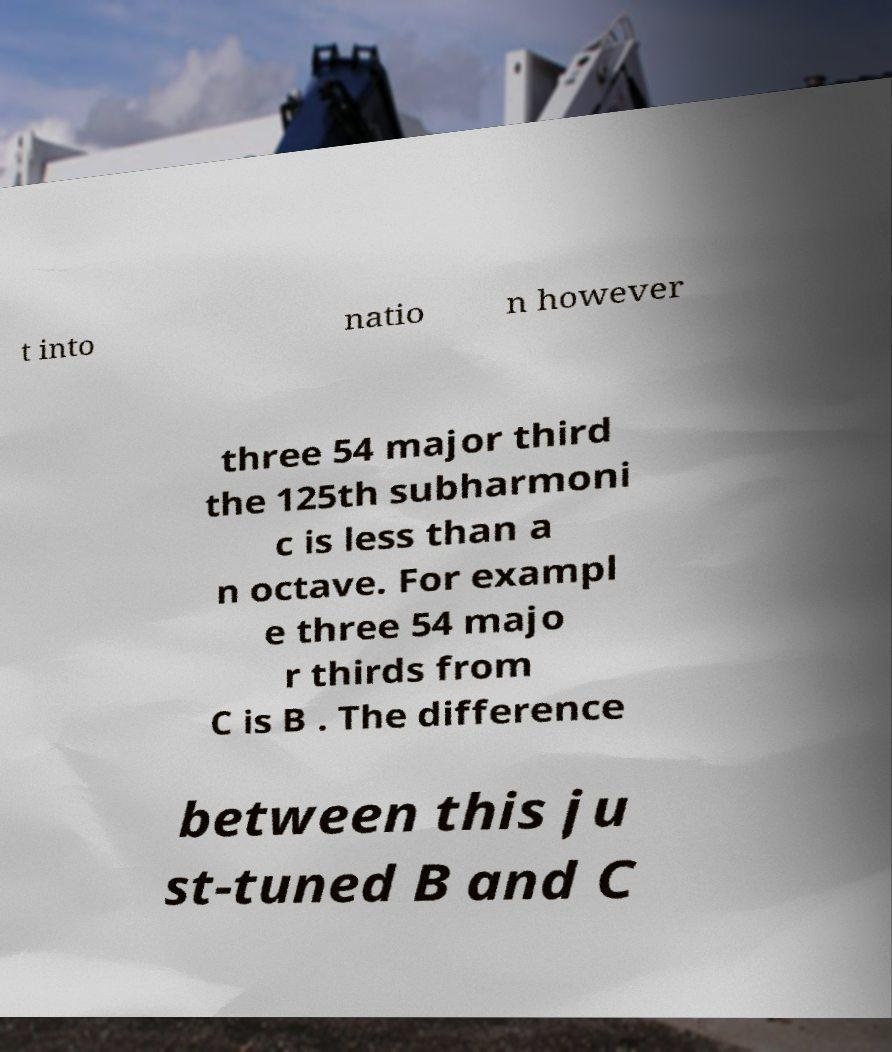Can you accurately transcribe the text from the provided image for me? t into natio n however three 54 major third the 125th subharmoni c is less than a n octave. For exampl e three 54 majo r thirds from C is B . The difference between this ju st-tuned B and C 